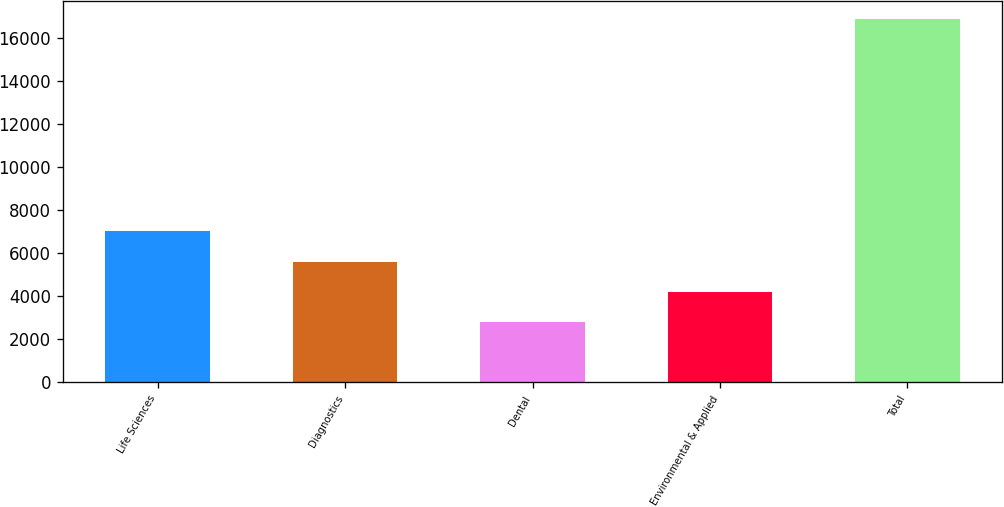<chart> <loc_0><loc_0><loc_500><loc_500><bar_chart><fcel>Life Sciences<fcel>Diagnostics<fcel>Dental<fcel>Environmental & Applied<fcel>Total<nl><fcel>7014.5<fcel>5604.8<fcel>2785.4<fcel>4195.1<fcel>16882.4<nl></chart> 